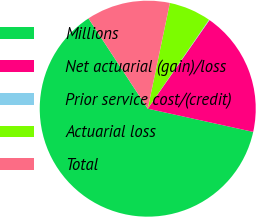Convert chart. <chart><loc_0><loc_0><loc_500><loc_500><pie_chart><fcel>Millions<fcel>Net actuarial (gain)/loss<fcel>Prior service cost/(credit)<fcel>Actuarial loss<fcel>Total<nl><fcel>62.3%<fcel>18.76%<fcel>0.09%<fcel>6.31%<fcel>12.53%<nl></chart> 